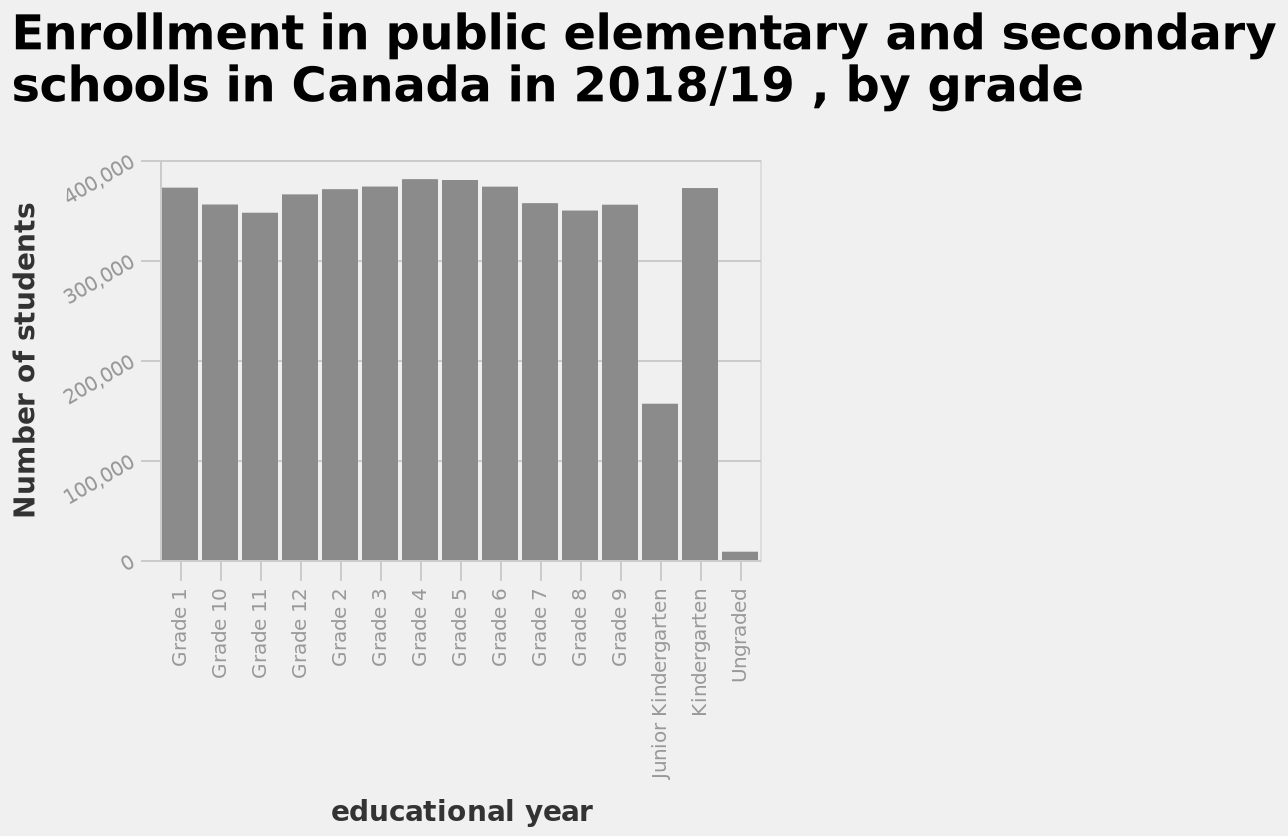<image>
Which grade level has the lowest enrollment? Junior Kindergarten and Ungraded have the lowest enrollment numbers. Does the enrollment fluctuate significantly between grades 1-10? No, the enrollment remains relatively steady across grades 1-10. 